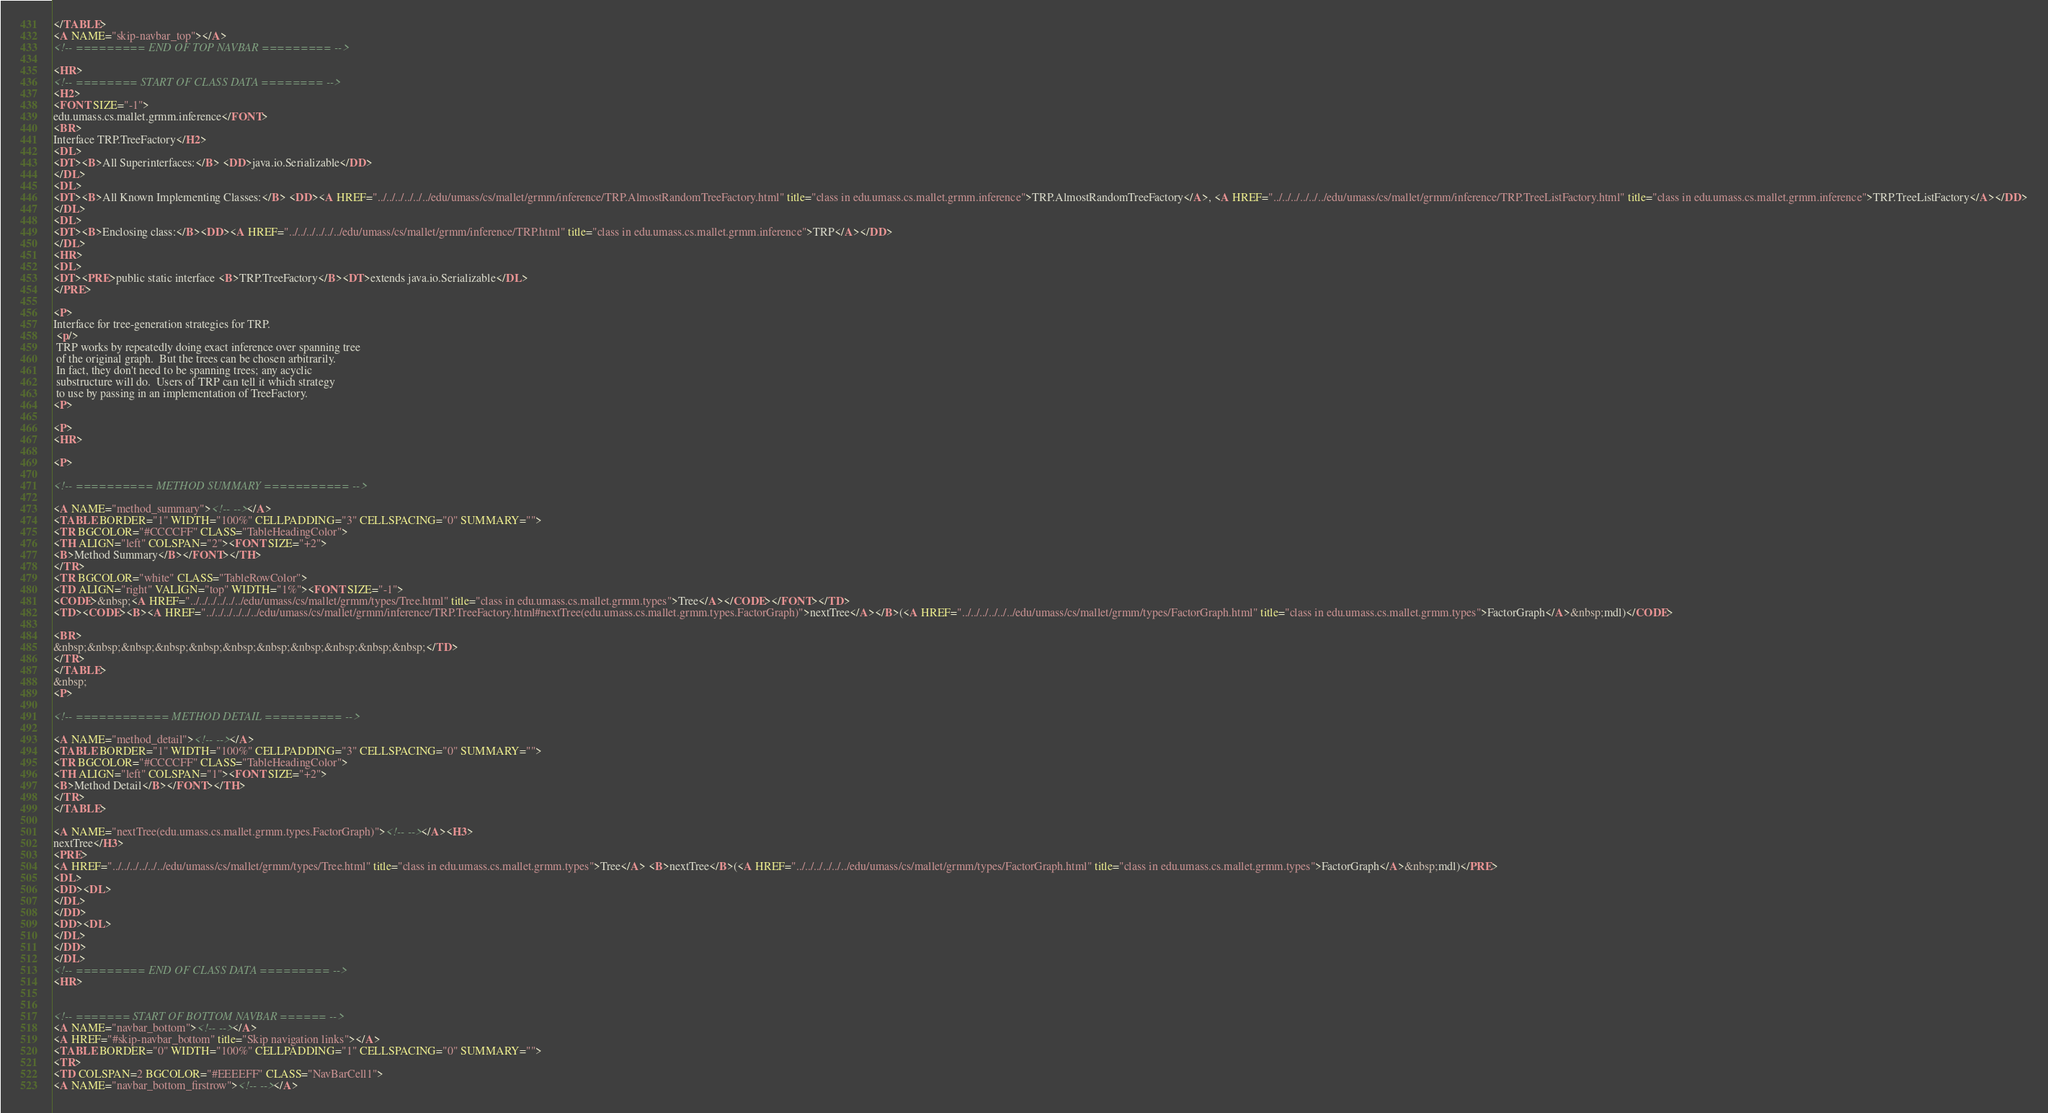<code> <loc_0><loc_0><loc_500><loc_500><_HTML_></TABLE>
<A NAME="skip-navbar_top"></A>
<!-- ========= END OF TOP NAVBAR ========= -->

<HR>
<!-- ======== START OF CLASS DATA ======== -->
<H2>
<FONT SIZE="-1">
edu.umass.cs.mallet.grmm.inference</FONT>
<BR>
Interface TRP.TreeFactory</H2>
<DL>
<DT><B>All Superinterfaces:</B> <DD>java.io.Serializable</DD>
</DL>
<DL>
<DT><B>All Known Implementing Classes:</B> <DD><A HREF="../../../../../../edu/umass/cs/mallet/grmm/inference/TRP.AlmostRandomTreeFactory.html" title="class in edu.umass.cs.mallet.grmm.inference">TRP.AlmostRandomTreeFactory</A>, <A HREF="../../../../../../edu/umass/cs/mallet/grmm/inference/TRP.TreeListFactory.html" title="class in edu.umass.cs.mallet.grmm.inference">TRP.TreeListFactory</A></DD>
</DL>
<DL>
<DT><B>Enclosing class:</B><DD><A HREF="../../../../../../edu/umass/cs/mallet/grmm/inference/TRP.html" title="class in edu.umass.cs.mallet.grmm.inference">TRP</A></DD>
</DL>
<HR>
<DL>
<DT><PRE>public static interface <B>TRP.TreeFactory</B><DT>extends java.io.Serializable</DL>
</PRE>

<P>
Interface for tree-generation strategies for TRP.
 <p/>
 TRP works by repeatedly doing exact inference over spanning tree
 of the original graph.  But the trees can be chosen arbitrarily.
 In fact, they don't need to be spanning trees; any acyclic
 substructure will do.  Users of TRP can tell it which strategy
 to use by passing in an implementation of TreeFactory.
<P>

<P>
<HR>

<P>

<!-- ========== METHOD SUMMARY =========== -->

<A NAME="method_summary"><!-- --></A>
<TABLE BORDER="1" WIDTH="100%" CELLPADDING="3" CELLSPACING="0" SUMMARY="">
<TR BGCOLOR="#CCCCFF" CLASS="TableHeadingColor">
<TH ALIGN="left" COLSPAN="2"><FONT SIZE="+2">
<B>Method Summary</B></FONT></TH>
</TR>
<TR BGCOLOR="white" CLASS="TableRowColor">
<TD ALIGN="right" VALIGN="top" WIDTH="1%"><FONT SIZE="-1">
<CODE>&nbsp;<A HREF="../../../../../../edu/umass/cs/mallet/grmm/types/Tree.html" title="class in edu.umass.cs.mallet.grmm.types">Tree</A></CODE></FONT></TD>
<TD><CODE><B><A HREF="../../../../../../edu/umass/cs/mallet/grmm/inference/TRP.TreeFactory.html#nextTree(edu.umass.cs.mallet.grmm.types.FactorGraph)">nextTree</A></B>(<A HREF="../../../../../../edu/umass/cs/mallet/grmm/types/FactorGraph.html" title="class in edu.umass.cs.mallet.grmm.types">FactorGraph</A>&nbsp;mdl)</CODE>

<BR>
&nbsp;&nbsp;&nbsp;&nbsp;&nbsp;&nbsp;&nbsp;&nbsp;&nbsp;&nbsp;&nbsp;</TD>
</TR>
</TABLE>
&nbsp;
<P>

<!-- ============ METHOD DETAIL ========== -->

<A NAME="method_detail"><!-- --></A>
<TABLE BORDER="1" WIDTH="100%" CELLPADDING="3" CELLSPACING="0" SUMMARY="">
<TR BGCOLOR="#CCCCFF" CLASS="TableHeadingColor">
<TH ALIGN="left" COLSPAN="1"><FONT SIZE="+2">
<B>Method Detail</B></FONT></TH>
</TR>
</TABLE>

<A NAME="nextTree(edu.umass.cs.mallet.grmm.types.FactorGraph)"><!-- --></A><H3>
nextTree</H3>
<PRE>
<A HREF="../../../../../../edu/umass/cs/mallet/grmm/types/Tree.html" title="class in edu.umass.cs.mallet.grmm.types">Tree</A> <B>nextTree</B>(<A HREF="../../../../../../edu/umass/cs/mallet/grmm/types/FactorGraph.html" title="class in edu.umass.cs.mallet.grmm.types">FactorGraph</A>&nbsp;mdl)</PRE>
<DL>
<DD><DL>
</DL>
</DD>
<DD><DL>
</DL>
</DD>
</DL>
<!-- ========= END OF CLASS DATA ========= -->
<HR>


<!-- ======= START OF BOTTOM NAVBAR ====== -->
<A NAME="navbar_bottom"><!-- --></A>
<A HREF="#skip-navbar_bottom" title="Skip navigation links"></A>
<TABLE BORDER="0" WIDTH="100%" CELLPADDING="1" CELLSPACING="0" SUMMARY="">
<TR>
<TD COLSPAN=2 BGCOLOR="#EEEEFF" CLASS="NavBarCell1">
<A NAME="navbar_bottom_firstrow"><!-- --></A></code> 